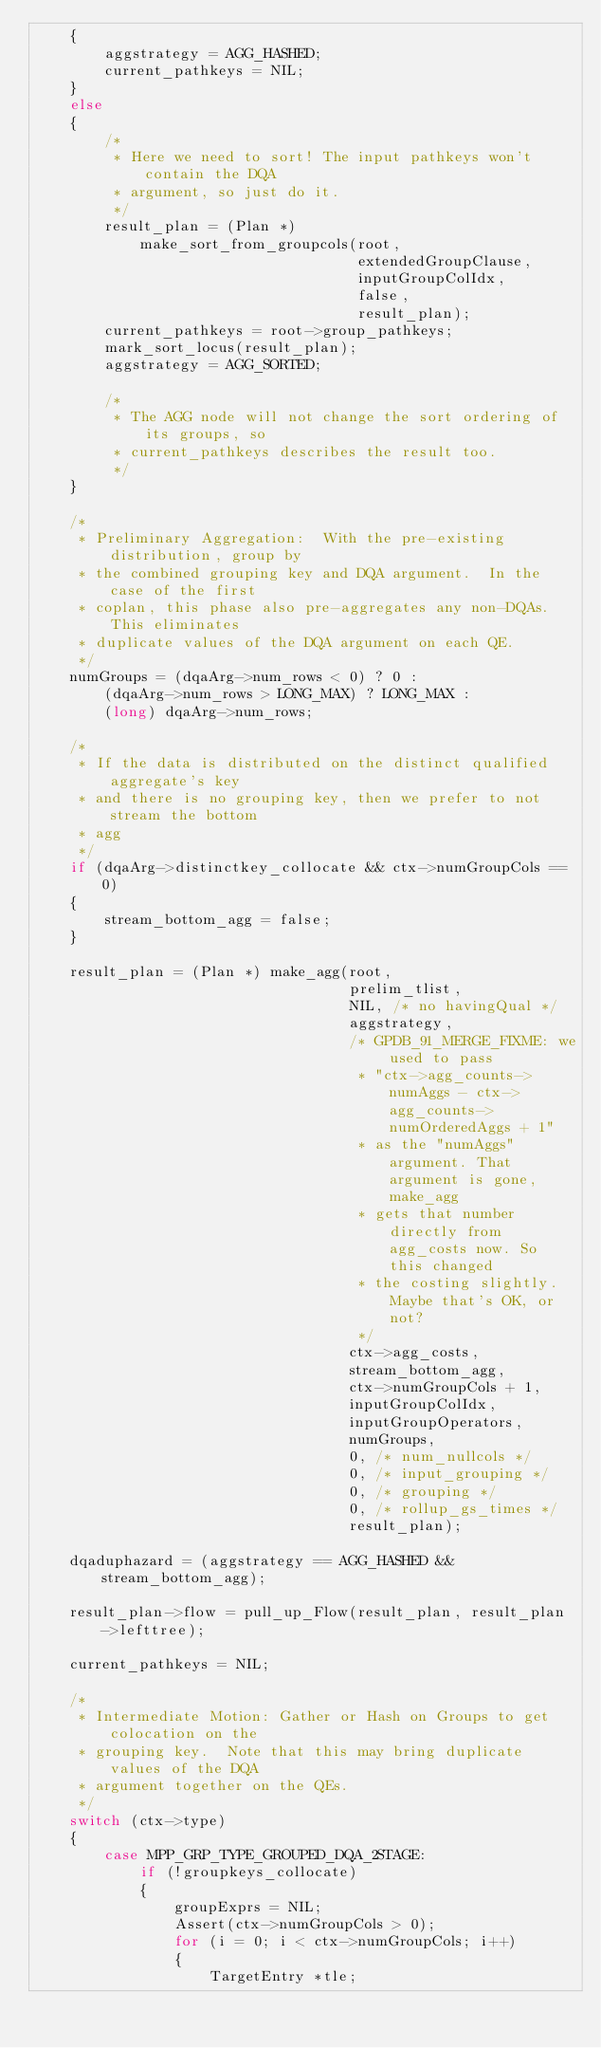<code> <loc_0><loc_0><loc_500><loc_500><_C_>	{
		aggstrategy = AGG_HASHED;
		current_pathkeys = NIL;
	}
	else
	{
		/*
		 * Here we need to sort! The input pathkeys won't contain the DQA
		 * argument, so just do it.
		 */
		result_plan = (Plan *)
			make_sort_from_groupcols(root,
									 extendedGroupClause,
									 inputGroupColIdx,
									 false,
									 result_plan);
		current_pathkeys = root->group_pathkeys;
		mark_sort_locus(result_plan);
		aggstrategy = AGG_SORTED;

		/*
		 * The AGG node will not change the sort ordering of its groups, so
		 * current_pathkeys describes the result too.
		 */
	}

	/*
	 * Preliminary Aggregation:  With the pre-existing distribution, group by
	 * the combined grouping key and DQA argument.  In the case of the first
	 * coplan, this phase also pre-aggregates any non-DQAs.  This eliminates
	 * duplicate values of the DQA argument on each QE.
	 */
	numGroups = (dqaArg->num_rows < 0) ? 0 :
		(dqaArg->num_rows > LONG_MAX) ? LONG_MAX :
		(long) dqaArg->num_rows;

	/*
	 * If the data is distributed on the distinct qualified aggregate's key
	 * and there is no grouping key, then we prefer to not stream the bottom
	 * agg
	 */
	if (dqaArg->distinctkey_collocate && ctx->numGroupCols == 0)
	{
		stream_bottom_agg = false;
	}

	result_plan = (Plan *) make_agg(root,
									prelim_tlist,
									NIL, /* no havingQual */
									aggstrategy,
									/* GPDB_91_MERGE_FIXME: we used to pass
									 * "ctx->agg_counts->numAggs - ctx->agg_counts->numOrderedAggs + 1"
									 * as the "numAggs" argument. That argument is gone, make_agg
									 * gets that number directly from agg_costs now. So this changed
									 * the costing slightly. Maybe that's OK, or not?
									 */
									ctx->agg_costs,
									stream_bottom_agg,
									ctx->numGroupCols + 1,
									inputGroupColIdx,
									inputGroupOperators,
									numGroups,
									0, /* num_nullcols */
									0, /* input_grouping */
									0, /* grouping */
									0, /* rollup_gs_times */
									result_plan);

	dqaduphazard = (aggstrategy == AGG_HASHED && stream_bottom_agg);

	result_plan->flow = pull_up_Flow(result_plan, result_plan->lefttree);

	current_pathkeys = NIL;

	/*
	 * Intermediate Motion: Gather or Hash on Groups to get colocation on the
	 * grouping key.  Note that this may bring duplicate values of the DQA
	 * argument together on the QEs.
	 */
	switch (ctx->type)
	{
		case MPP_GRP_TYPE_GROUPED_DQA_2STAGE:
			if (!groupkeys_collocate)
			{
				groupExprs = NIL;
				Assert(ctx->numGroupCols > 0);
				for (i = 0; i < ctx->numGroupCols; i++)
				{
					TargetEntry *tle;
</code> 